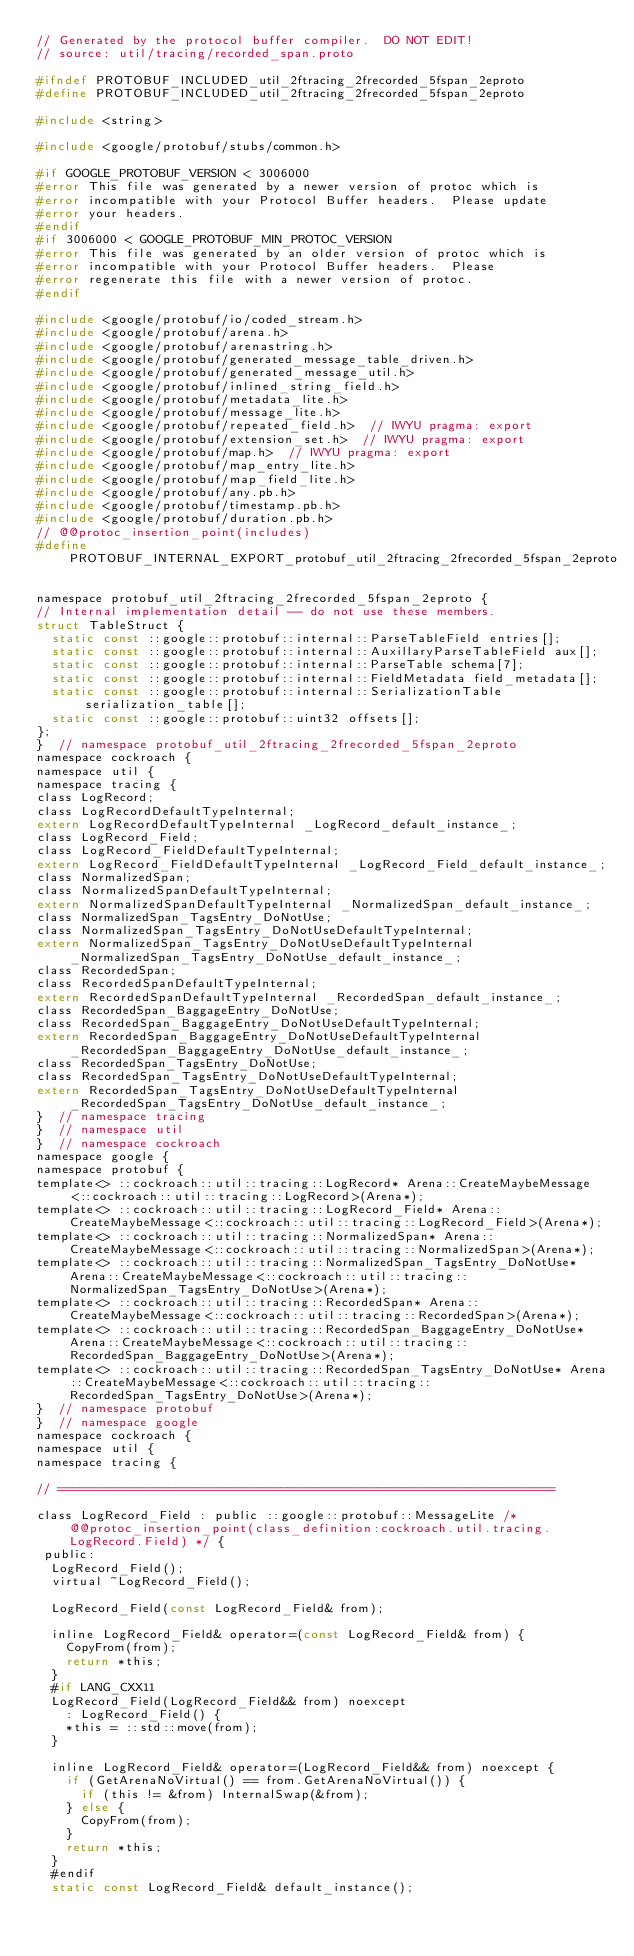<code> <loc_0><loc_0><loc_500><loc_500><_C_>// Generated by the protocol buffer compiler.  DO NOT EDIT!
// source: util/tracing/recorded_span.proto

#ifndef PROTOBUF_INCLUDED_util_2ftracing_2frecorded_5fspan_2eproto
#define PROTOBUF_INCLUDED_util_2ftracing_2frecorded_5fspan_2eproto

#include <string>

#include <google/protobuf/stubs/common.h>

#if GOOGLE_PROTOBUF_VERSION < 3006000
#error This file was generated by a newer version of protoc which is
#error incompatible with your Protocol Buffer headers.  Please update
#error your headers.
#endif
#if 3006000 < GOOGLE_PROTOBUF_MIN_PROTOC_VERSION
#error This file was generated by an older version of protoc which is
#error incompatible with your Protocol Buffer headers.  Please
#error regenerate this file with a newer version of protoc.
#endif

#include <google/protobuf/io/coded_stream.h>
#include <google/protobuf/arena.h>
#include <google/protobuf/arenastring.h>
#include <google/protobuf/generated_message_table_driven.h>
#include <google/protobuf/generated_message_util.h>
#include <google/protobuf/inlined_string_field.h>
#include <google/protobuf/metadata_lite.h>
#include <google/protobuf/message_lite.h>
#include <google/protobuf/repeated_field.h>  // IWYU pragma: export
#include <google/protobuf/extension_set.h>  // IWYU pragma: export
#include <google/protobuf/map.h>  // IWYU pragma: export
#include <google/protobuf/map_entry_lite.h>
#include <google/protobuf/map_field_lite.h>
#include <google/protobuf/any.pb.h>
#include <google/protobuf/timestamp.pb.h>
#include <google/protobuf/duration.pb.h>
// @@protoc_insertion_point(includes)
#define PROTOBUF_INTERNAL_EXPORT_protobuf_util_2ftracing_2frecorded_5fspan_2eproto 

namespace protobuf_util_2ftracing_2frecorded_5fspan_2eproto {
// Internal implementation detail -- do not use these members.
struct TableStruct {
  static const ::google::protobuf::internal::ParseTableField entries[];
  static const ::google::protobuf::internal::AuxillaryParseTableField aux[];
  static const ::google::protobuf::internal::ParseTable schema[7];
  static const ::google::protobuf::internal::FieldMetadata field_metadata[];
  static const ::google::protobuf::internal::SerializationTable serialization_table[];
  static const ::google::protobuf::uint32 offsets[];
};
}  // namespace protobuf_util_2ftracing_2frecorded_5fspan_2eproto
namespace cockroach {
namespace util {
namespace tracing {
class LogRecord;
class LogRecordDefaultTypeInternal;
extern LogRecordDefaultTypeInternal _LogRecord_default_instance_;
class LogRecord_Field;
class LogRecord_FieldDefaultTypeInternal;
extern LogRecord_FieldDefaultTypeInternal _LogRecord_Field_default_instance_;
class NormalizedSpan;
class NormalizedSpanDefaultTypeInternal;
extern NormalizedSpanDefaultTypeInternal _NormalizedSpan_default_instance_;
class NormalizedSpan_TagsEntry_DoNotUse;
class NormalizedSpan_TagsEntry_DoNotUseDefaultTypeInternal;
extern NormalizedSpan_TagsEntry_DoNotUseDefaultTypeInternal _NormalizedSpan_TagsEntry_DoNotUse_default_instance_;
class RecordedSpan;
class RecordedSpanDefaultTypeInternal;
extern RecordedSpanDefaultTypeInternal _RecordedSpan_default_instance_;
class RecordedSpan_BaggageEntry_DoNotUse;
class RecordedSpan_BaggageEntry_DoNotUseDefaultTypeInternal;
extern RecordedSpan_BaggageEntry_DoNotUseDefaultTypeInternal _RecordedSpan_BaggageEntry_DoNotUse_default_instance_;
class RecordedSpan_TagsEntry_DoNotUse;
class RecordedSpan_TagsEntry_DoNotUseDefaultTypeInternal;
extern RecordedSpan_TagsEntry_DoNotUseDefaultTypeInternal _RecordedSpan_TagsEntry_DoNotUse_default_instance_;
}  // namespace tracing
}  // namespace util
}  // namespace cockroach
namespace google {
namespace protobuf {
template<> ::cockroach::util::tracing::LogRecord* Arena::CreateMaybeMessage<::cockroach::util::tracing::LogRecord>(Arena*);
template<> ::cockroach::util::tracing::LogRecord_Field* Arena::CreateMaybeMessage<::cockroach::util::tracing::LogRecord_Field>(Arena*);
template<> ::cockroach::util::tracing::NormalizedSpan* Arena::CreateMaybeMessage<::cockroach::util::tracing::NormalizedSpan>(Arena*);
template<> ::cockroach::util::tracing::NormalizedSpan_TagsEntry_DoNotUse* Arena::CreateMaybeMessage<::cockroach::util::tracing::NormalizedSpan_TagsEntry_DoNotUse>(Arena*);
template<> ::cockroach::util::tracing::RecordedSpan* Arena::CreateMaybeMessage<::cockroach::util::tracing::RecordedSpan>(Arena*);
template<> ::cockroach::util::tracing::RecordedSpan_BaggageEntry_DoNotUse* Arena::CreateMaybeMessage<::cockroach::util::tracing::RecordedSpan_BaggageEntry_DoNotUse>(Arena*);
template<> ::cockroach::util::tracing::RecordedSpan_TagsEntry_DoNotUse* Arena::CreateMaybeMessage<::cockroach::util::tracing::RecordedSpan_TagsEntry_DoNotUse>(Arena*);
}  // namespace protobuf
}  // namespace google
namespace cockroach {
namespace util {
namespace tracing {

// ===================================================================

class LogRecord_Field : public ::google::protobuf::MessageLite /* @@protoc_insertion_point(class_definition:cockroach.util.tracing.LogRecord.Field) */ {
 public:
  LogRecord_Field();
  virtual ~LogRecord_Field();

  LogRecord_Field(const LogRecord_Field& from);

  inline LogRecord_Field& operator=(const LogRecord_Field& from) {
    CopyFrom(from);
    return *this;
  }
  #if LANG_CXX11
  LogRecord_Field(LogRecord_Field&& from) noexcept
    : LogRecord_Field() {
    *this = ::std::move(from);
  }

  inline LogRecord_Field& operator=(LogRecord_Field&& from) noexcept {
    if (GetArenaNoVirtual() == from.GetArenaNoVirtual()) {
      if (this != &from) InternalSwap(&from);
    } else {
      CopyFrom(from);
    }
    return *this;
  }
  #endif
  static const LogRecord_Field& default_instance();
</code> 